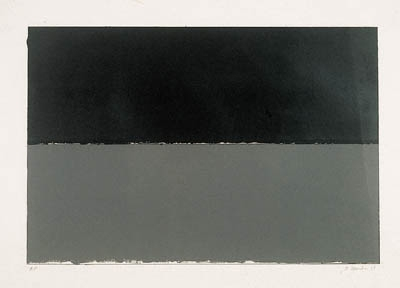Can you describe the main features of this image for me?
 The image you've shared is a striking example of minimalist art. It features two rectangles, one atop the other, each filled with a different color. The upper rectangle is filled with a deep black color, while the lower rectangle is a shade of gray. Separating these two rectangles is a thin white line, providing a stark contrast against the darker colors. The art style is abstract, with the simplicity and use of geometric shapes being characteristic of the minimalism genre. The image doesn't attempt to represent an accurate depiction of visual reality, instead, it uses shapes and colors to achieve its effect. It's a piece that invites viewers to appreciate the beauty in simplicity and the power of color and form. 